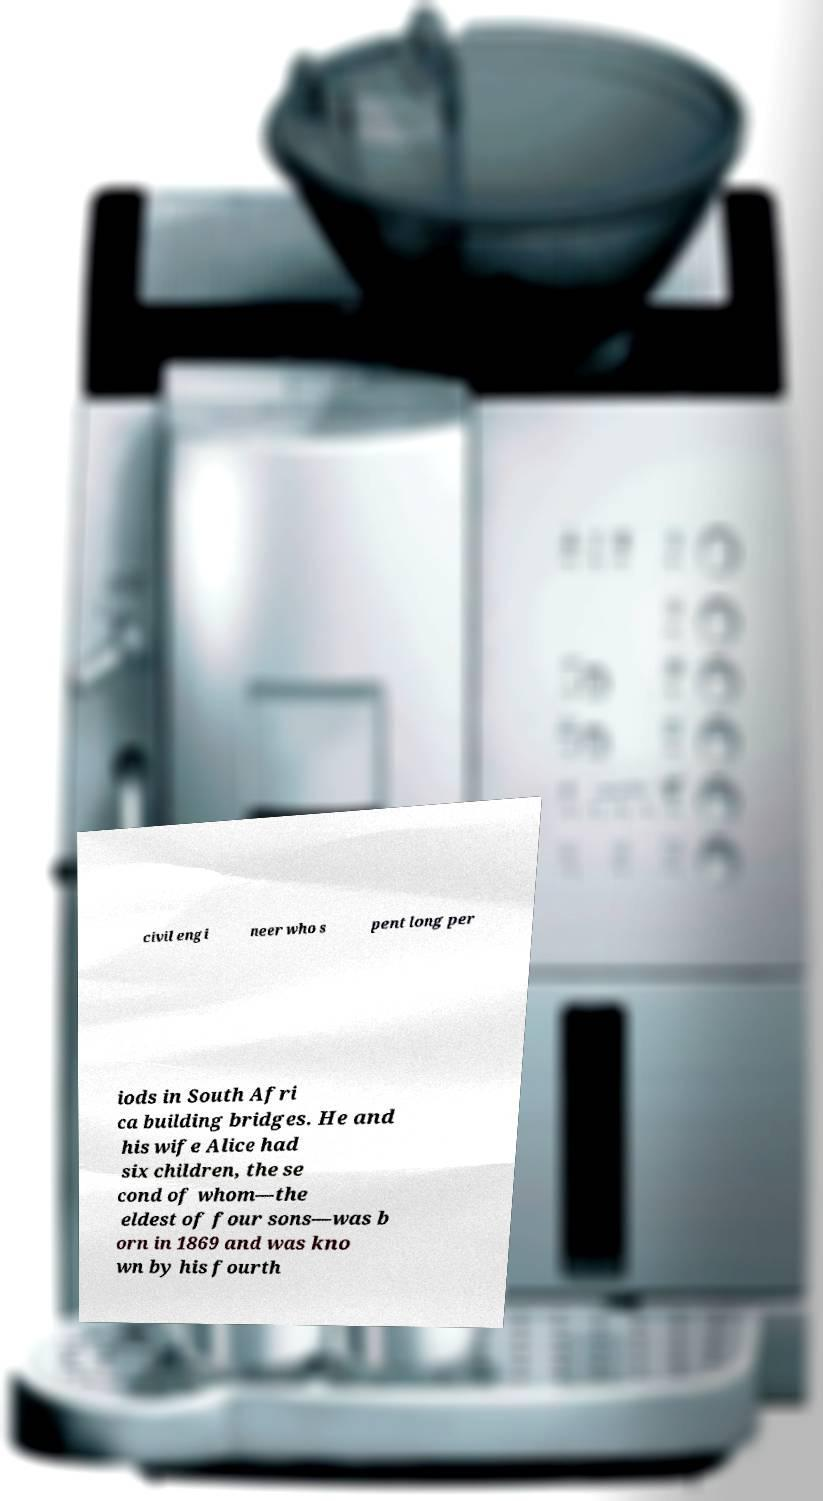For documentation purposes, I need the text within this image transcribed. Could you provide that? civil engi neer who s pent long per iods in South Afri ca building bridges. He and his wife Alice had six children, the se cond of whom—the eldest of four sons—was b orn in 1869 and was kno wn by his fourth 